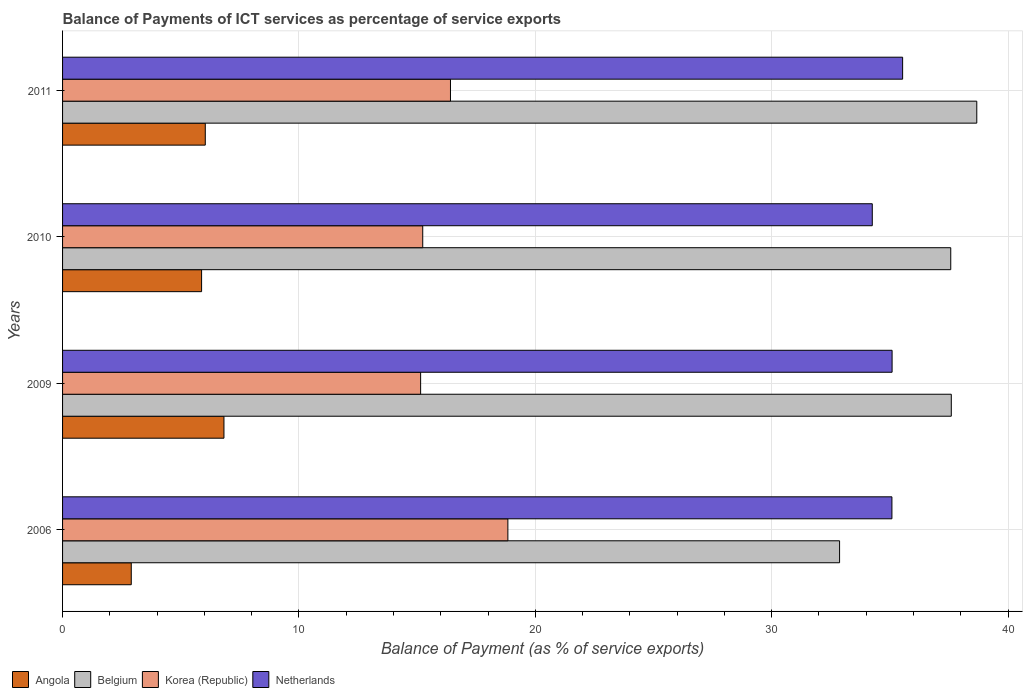How many different coloured bars are there?
Make the answer very short. 4. Are the number of bars per tick equal to the number of legend labels?
Keep it short and to the point. Yes. How many bars are there on the 3rd tick from the top?
Your answer should be compact. 4. In how many cases, is the number of bars for a given year not equal to the number of legend labels?
Give a very brief answer. 0. What is the balance of payments of ICT services in Belgium in 2011?
Make the answer very short. 38.68. Across all years, what is the maximum balance of payments of ICT services in Angola?
Make the answer very short. 6.83. Across all years, what is the minimum balance of payments of ICT services in Belgium?
Your response must be concise. 32.87. In which year was the balance of payments of ICT services in Netherlands maximum?
Your answer should be very brief. 2011. In which year was the balance of payments of ICT services in Netherlands minimum?
Ensure brevity in your answer.  2010. What is the total balance of payments of ICT services in Korea (Republic) in the graph?
Give a very brief answer. 65.63. What is the difference between the balance of payments of ICT services in Korea (Republic) in 2009 and that in 2011?
Your answer should be very brief. -1.26. What is the difference between the balance of payments of ICT services in Korea (Republic) in 2006 and the balance of payments of ICT services in Angola in 2011?
Give a very brief answer. 12.8. What is the average balance of payments of ICT services in Angola per year?
Provide a short and direct response. 5.41. In the year 2009, what is the difference between the balance of payments of ICT services in Netherlands and balance of payments of ICT services in Belgium?
Your response must be concise. -2.5. In how many years, is the balance of payments of ICT services in Belgium greater than 2 %?
Give a very brief answer. 4. What is the ratio of the balance of payments of ICT services in Belgium in 2006 to that in 2009?
Offer a very short reply. 0.87. Is the balance of payments of ICT services in Angola in 2006 less than that in 2009?
Your answer should be very brief. Yes. Is the difference between the balance of payments of ICT services in Netherlands in 2006 and 2011 greater than the difference between the balance of payments of ICT services in Belgium in 2006 and 2011?
Keep it short and to the point. Yes. What is the difference between the highest and the second highest balance of payments of ICT services in Netherlands?
Your response must be concise. 0.45. What is the difference between the highest and the lowest balance of payments of ICT services in Korea (Republic)?
Your response must be concise. 3.69. In how many years, is the balance of payments of ICT services in Netherlands greater than the average balance of payments of ICT services in Netherlands taken over all years?
Provide a short and direct response. 3. Is the sum of the balance of payments of ICT services in Korea (Republic) in 2006 and 2010 greater than the maximum balance of payments of ICT services in Belgium across all years?
Offer a terse response. No. Is it the case that in every year, the sum of the balance of payments of ICT services in Angola and balance of payments of ICT services in Netherlands is greater than the balance of payments of ICT services in Korea (Republic)?
Your response must be concise. Yes. How many bars are there?
Offer a very short reply. 16. Are all the bars in the graph horizontal?
Make the answer very short. Yes. How many years are there in the graph?
Ensure brevity in your answer.  4. What is the difference between two consecutive major ticks on the X-axis?
Your answer should be very brief. 10. Are the values on the major ticks of X-axis written in scientific E-notation?
Give a very brief answer. No. Where does the legend appear in the graph?
Offer a very short reply. Bottom left. How many legend labels are there?
Provide a short and direct response. 4. How are the legend labels stacked?
Your response must be concise. Horizontal. What is the title of the graph?
Provide a short and direct response. Balance of Payments of ICT services as percentage of service exports. What is the label or title of the X-axis?
Make the answer very short. Balance of Payment (as % of service exports). What is the label or title of the Y-axis?
Offer a terse response. Years. What is the Balance of Payment (as % of service exports) in Angola in 2006?
Provide a short and direct response. 2.91. What is the Balance of Payment (as % of service exports) in Belgium in 2006?
Your answer should be compact. 32.87. What is the Balance of Payment (as % of service exports) of Korea (Republic) in 2006?
Give a very brief answer. 18.84. What is the Balance of Payment (as % of service exports) in Netherlands in 2006?
Make the answer very short. 35.09. What is the Balance of Payment (as % of service exports) in Angola in 2009?
Keep it short and to the point. 6.83. What is the Balance of Payment (as % of service exports) in Belgium in 2009?
Offer a terse response. 37.6. What is the Balance of Payment (as % of service exports) in Korea (Republic) in 2009?
Give a very brief answer. 15.15. What is the Balance of Payment (as % of service exports) of Netherlands in 2009?
Ensure brevity in your answer.  35.09. What is the Balance of Payment (as % of service exports) of Angola in 2010?
Offer a very short reply. 5.88. What is the Balance of Payment (as % of service exports) in Belgium in 2010?
Ensure brevity in your answer.  37.57. What is the Balance of Payment (as % of service exports) in Korea (Republic) in 2010?
Offer a terse response. 15.24. What is the Balance of Payment (as % of service exports) of Netherlands in 2010?
Your response must be concise. 34.25. What is the Balance of Payment (as % of service exports) in Angola in 2011?
Your response must be concise. 6.04. What is the Balance of Payment (as % of service exports) of Belgium in 2011?
Your response must be concise. 38.68. What is the Balance of Payment (as % of service exports) of Korea (Republic) in 2011?
Your response must be concise. 16.41. What is the Balance of Payment (as % of service exports) of Netherlands in 2011?
Provide a succinct answer. 35.54. Across all years, what is the maximum Balance of Payment (as % of service exports) of Angola?
Offer a very short reply. 6.83. Across all years, what is the maximum Balance of Payment (as % of service exports) of Belgium?
Your answer should be very brief. 38.68. Across all years, what is the maximum Balance of Payment (as % of service exports) of Korea (Republic)?
Your answer should be very brief. 18.84. Across all years, what is the maximum Balance of Payment (as % of service exports) in Netherlands?
Your answer should be compact. 35.54. Across all years, what is the minimum Balance of Payment (as % of service exports) in Angola?
Provide a succinct answer. 2.91. Across all years, what is the minimum Balance of Payment (as % of service exports) of Belgium?
Make the answer very short. 32.87. Across all years, what is the minimum Balance of Payment (as % of service exports) in Korea (Republic)?
Offer a very short reply. 15.15. Across all years, what is the minimum Balance of Payment (as % of service exports) of Netherlands?
Your response must be concise. 34.25. What is the total Balance of Payment (as % of service exports) of Angola in the graph?
Offer a very short reply. 21.65. What is the total Balance of Payment (as % of service exports) of Belgium in the graph?
Give a very brief answer. 146.72. What is the total Balance of Payment (as % of service exports) of Korea (Republic) in the graph?
Your response must be concise. 65.63. What is the total Balance of Payment (as % of service exports) in Netherlands in the graph?
Keep it short and to the point. 139.97. What is the difference between the Balance of Payment (as % of service exports) of Angola in 2006 and that in 2009?
Your response must be concise. -3.92. What is the difference between the Balance of Payment (as % of service exports) of Belgium in 2006 and that in 2009?
Your answer should be very brief. -4.73. What is the difference between the Balance of Payment (as % of service exports) in Korea (Republic) in 2006 and that in 2009?
Offer a very short reply. 3.69. What is the difference between the Balance of Payment (as % of service exports) in Netherlands in 2006 and that in 2009?
Offer a terse response. -0.01. What is the difference between the Balance of Payment (as % of service exports) in Angola in 2006 and that in 2010?
Give a very brief answer. -2.98. What is the difference between the Balance of Payment (as % of service exports) in Belgium in 2006 and that in 2010?
Keep it short and to the point. -4.7. What is the difference between the Balance of Payment (as % of service exports) of Korea (Republic) in 2006 and that in 2010?
Offer a terse response. 3.6. What is the difference between the Balance of Payment (as % of service exports) in Netherlands in 2006 and that in 2010?
Ensure brevity in your answer.  0.83. What is the difference between the Balance of Payment (as % of service exports) in Angola in 2006 and that in 2011?
Your response must be concise. -3.13. What is the difference between the Balance of Payment (as % of service exports) in Belgium in 2006 and that in 2011?
Offer a very short reply. -5.8. What is the difference between the Balance of Payment (as % of service exports) of Korea (Republic) in 2006 and that in 2011?
Give a very brief answer. 2.43. What is the difference between the Balance of Payment (as % of service exports) in Netherlands in 2006 and that in 2011?
Ensure brevity in your answer.  -0.45. What is the difference between the Balance of Payment (as % of service exports) of Angola in 2009 and that in 2010?
Provide a short and direct response. 0.95. What is the difference between the Balance of Payment (as % of service exports) in Belgium in 2009 and that in 2010?
Your answer should be compact. 0.02. What is the difference between the Balance of Payment (as % of service exports) in Korea (Republic) in 2009 and that in 2010?
Make the answer very short. -0.09. What is the difference between the Balance of Payment (as % of service exports) in Netherlands in 2009 and that in 2010?
Provide a short and direct response. 0.84. What is the difference between the Balance of Payment (as % of service exports) in Angola in 2009 and that in 2011?
Provide a short and direct response. 0.79. What is the difference between the Balance of Payment (as % of service exports) of Belgium in 2009 and that in 2011?
Your answer should be compact. -1.08. What is the difference between the Balance of Payment (as % of service exports) of Korea (Republic) in 2009 and that in 2011?
Ensure brevity in your answer.  -1.26. What is the difference between the Balance of Payment (as % of service exports) of Netherlands in 2009 and that in 2011?
Provide a short and direct response. -0.45. What is the difference between the Balance of Payment (as % of service exports) in Angola in 2010 and that in 2011?
Keep it short and to the point. -0.16. What is the difference between the Balance of Payment (as % of service exports) in Belgium in 2010 and that in 2011?
Offer a very short reply. -1.1. What is the difference between the Balance of Payment (as % of service exports) of Korea (Republic) in 2010 and that in 2011?
Keep it short and to the point. -1.17. What is the difference between the Balance of Payment (as % of service exports) in Netherlands in 2010 and that in 2011?
Offer a terse response. -1.28. What is the difference between the Balance of Payment (as % of service exports) in Angola in 2006 and the Balance of Payment (as % of service exports) in Belgium in 2009?
Your answer should be very brief. -34.69. What is the difference between the Balance of Payment (as % of service exports) of Angola in 2006 and the Balance of Payment (as % of service exports) of Korea (Republic) in 2009?
Your answer should be compact. -12.24. What is the difference between the Balance of Payment (as % of service exports) of Angola in 2006 and the Balance of Payment (as % of service exports) of Netherlands in 2009?
Keep it short and to the point. -32.19. What is the difference between the Balance of Payment (as % of service exports) of Belgium in 2006 and the Balance of Payment (as % of service exports) of Korea (Republic) in 2009?
Provide a short and direct response. 17.72. What is the difference between the Balance of Payment (as % of service exports) in Belgium in 2006 and the Balance of Payment (as % of service exports) in Netherlands in 2009?
Give a very brief answer. -2.22. What is the difference between the Balance of Payment (as % of service exports) of Korea (Republic) in 2006 and the Balance of Payment (as % of service exports) of Netherlands in 2009?
Make the answer very short. -16.25. What is the difference between the Balance of Payment (as % of service exports) of Angola in 2006 and the Balance of Payment (as % of service exports) of Belgium in 2010?
Your answer should be compact. -34.67. What is the difference between the Balance of Payment (as % of service exports) of Angola in 2006 and the Balance of Payment (as % of service exports) of Korea (Republic) in 2010?
Make the answer very short. -12.33. What is the difference between the Balance of Payment (as % of service exports) of Angola in 2006 and the Balance of Payment (as % of service exports) of Netherlands in 2010?
Your answer should be very brief. -31.35. What is the difference between the Balance of Payment (as % of service exports) of Belgium in 2006 and the Balance of Payment (as % of service exports) of Korea (Republic) in 2010?
Offer a very short reply. 17.63. What is the difference between the Balance of Payment (as % of service exports) in Belgium in 2006 and the Balance of Payment (as % of service exports) in Netherlands in 2010?
Provide a succinct answer. -1.38. What is the difference between the Balance of Payment (as % of service exports) of Korea (Republic) in 2006 and the Balance of Payment (as % of service exports) of Netherlands in 2010?
Offer a very short reply. -15.42. What is the difference between the Balance of Payment (as % of service exports) of Angola in 2006 and the Balance of Payment (as % of service exports) of Belgium in 2011?
Ensure brevity in your answer.  -35.77. What is the difference between the Balance of Payment (as % of service exports) in Angola in 2006 and the Balance of Payment (as % of service exports) in Korea (Republic) in 2011?
Your answer should be compact. -13.5. What is the difference between the Balance of Payment (as % of service exports) of Angola in 2006 and the Balance of Payment (as % of service exports) of Netherlands in 2011?
Make the answer very short. -32.63. What is the difference between the Balance of Payment (as % of service exports) of Belgium in 2006 and the Balance of Payment (as % of service exports) of Korea (Republic) in 2011?
Offer a terse response. 16.46. What is the difference between the Balance of Payment (as % of service exports) in Belgium in 2006 and the Balance of Payment (as % of service exports) in Netherlands in 2011?
Offer a very short reply. -2.67. What is the difference between the Balance of Payment (as % of service exports) in Korea (Republic) in 2006 and the Balance of Payment (as % of service exports) in Netherlands in 2011?
Provide a short and direct response. -16.7. What is the difference between the Balance of Payment (as % of service exports) in Angola in 2009 and the Balance of Payment (as % of service exports) in Belgium in 2010?
Ensure brevity in your answer.  -30.75. What is the difference between the Balance of Payment (as % of service exports) in Angola in 2009 and the Balance of Payment (as % of service exports) in Korea (Republic) in 2010?
Provide a succinct answer. -8.41. What is the difference between the Balance of Payment (as % of service exports) in Angola in 2009 and the Balance of Payment (as % of service exports) in Netherlands in 2010?
Offer a terse response. -27.43. What is the difference between the Balance of Payment (as % of service exports) in Belgium in 2009 and the Balance of Payment (as % of service exports) in Korea (Republic) in 2010?
Your answer should be compact. 22.36. What is the difference between the Balance of Payment (as % of service exports) in Belgium in 2009 and the Balance of Payment (as % of service exports) in Netherlands in 2010?
Ensure brevity in your answer.  3.34. What is the difference between the Balance of Payment (as % of service exports) in Korea (Republic) in 2009 and the Balance of Payment (as % of service exports) in Netherlands in 2010?
Your answer should be very brief. -19.11. What is the difference between the Balance of Payment (as % of service exports) of Angola in 2009 and the Balance of Payment (as % of service exports) of Belgium in 2011?
Your response must be concise. -31.85. What is the difference between the Balance of Payment (as % of service exports) of Angola in 2009 and the Balance of Payment (as % of service exports) of Korea (Republic) in 2011?
Your answer should be very brief. -9.58. What is the difference between the Balance of Payment (as % of service exports) of Angola in 2009 and the Balance of Payment (as % of service exports) of Netherlands in 2011?
Provide a short and direct response. -28.71. What is the difference between the Balance of Payment (as % of service exports) in Belgium in 2009 and the Balance of Payment (as % of service exports) in Korea (Republic) in 2011?
Keep it short and to the point. 21.19. What is the difference between the Balance of Payment (as % of service exports) of Belgium in 2009 and the Balance of Payment (as % of service exports) of Netherlands in 2011?
Keep it short and to the point. 2.06. What is the difference between the Balance of Payment (as % of service exports) of Korea (Republic) in 2009 and the Balance of Payment (as % of service exports) of Netherlands in 2011?
Your answer should be compact. -20.39. What is the difference between the Balance of Payment (as % of service exports) of Angola in 2010 and the Balance of Payment (as % of service exports) of Belgium in 2011?
Offer a terse response. -32.79. What is the difference between the Balance of Payment (as % of service exports) in Angola in 2010 and the Balance of Payment (as % of service exports) in Korea (Republic) in 2011?
Ensure brevity in your answer.  -10.53. What is the difference between the Balance of Payment (as % of service exports) in Angola in 2010 and the Balance of Payment (as % of service exports) in Netherlands in 2011?
Offer a terse response. -29.66. What is the difference between the Balance of Payment (as % of service exports) in Belgium in 2010 and the Balance of Payment (as % of service exports) in Korea (Republic) in 2011?
Give a very brief answer. 21.16. What is the difference between the Balance of Payment (as % of service exports) of Belgium in 2010 and the Balance of Payment (as % of service exports) of Netherlands in 2011?
Keep it short and to the point. 2.04. What is the difference between the Balance of Payment (as % of service exports) in Korea (Republic) in 2010 and the Balance of Payment (as % of service exports) in Netherlands in 2011?
Offer a terse response. -20.3. What is the average Balance of Payment (as % of service exports) in Angola per year?
Ensure brevity in your answer.  5.41. What is the average Balance of Payment (as % of service exports) in Belgium per year?
Keep it short and to the point. 36.68. What is the average Balance of Payment (as % of service exports) in Korea (Republic) per year?
Give a very brief answer. 16.41. What is the average Balance of Payment (as % of service exports) of Netherlands per year?
Ensure brevity in your answer.  34.99. In the year 2006, what is the difference between the Balance of Payment (as % of service exports) in Angola and Balance of Payment (as % of service exports) in Belgium?
Offer a very short reply. -29.96. In the year 2006, what is the difference between the Balance of Payment (as % of service exports) of Angola and Balance of Payment (as % of service exports) of Korea (Republic)?
Give a very brief answer. -15.93. In the year 2006, what is the difference between the Balance of Payment (as % of service exports) in Angola and Balance of Payment (as % of service exports) in Netherlands?
Provide a short and direct response. -32.18. In the year 2006, what is the difference between the Balance of Payment (as % of service exports) in Belgium and Balance of Payment (as % of service exports) in Korea (Republic)?
Ensure brevity in your answer.  14.03. In the year 2006, what is the difference between the Balance of Payment (as % of service exports) in Belgium and Balance of Payment (as % of service exports) in Netherlands?
Your response must be concise. -2.21. In the year 2006, what is the difference between the Balance of Payment (as % of service exports) of Korea (Republic) and Balance of Payment (as % of service exports) of Netherlands?
Give a very brief answer. -16.25. In the year 2009, what is the difference between the Balance of Payment (as % of service exports) of Angola and Balance of Payment (as % of service exports) of Belgium?
Offer a terse response. -30.77. In the year 2009, what is the difference between the Balance of Payment (as % of service exports) of Angola and Balance of Payment (as % of service exports) of Korea (Republic)?
Your response must be concise. -8.32. In the year 2009, what is the difference between the Balance of Payment (as % of service exports) in Angola and Balance of Payment (as % of service exports) in Netherlands?
Ensure brevity in your answer.  -28.27. In the year 2009, what is the difference between the Balance of Payment (as % of service exports) in Belgium and Balance of Payment (as % of service exports) in Korea (Republic)?
Ensure brevity in your answer.  22.45. In the year 2009, what is the difference between the Balance of Payment (as % of service exports) in Belgium and Balance of Payment (as % of service exports) in Netherlands?
Provide a succinct answer. 2.5. In the year 2009, what is the difference between the Balance of Payment (as % of service exports) in Korea (Republic) and Balance of Payment (as % of service exports) in Netherlands?
Offer a terse response. -19.94. In the year 2010, what is the difference between the Balance of Payment (as % of service exports) of Angola and Balance of Payment (as % of service exports) of Belgium?
Offer a very short reply. -31.69. In the year 2010, what is the difference between the Balance of Payment (as % of service exports) of Angola and Balance of Payment (as % of service exports) of Korea (Republic)?
Provide a short and direct response. -9.36. In the year 2010, what is the difference between the Balance of Payment (as % of service exports) of Angola and Balance of Payment (as % of service exports) of Netherlands?
Your response must be concise. -28.37. In the year 2010, what is the difference between the Balance of Payment (as % of service exports) of Belgium and Balance of Payment (as % of service exports) of Korea (Republic)?
Make the answer very short. 22.34. In the year 2010, what is the difference between the Balance of Payment (as % of service exports) of Belgium and Balance of Payment (as % of service exports) of Netherlands?
Give a very brief answer. 3.32. In the year 2010, what is the difference between the Balance of Payment (as % of service exports) of Korea (Republic) and Balance of Payment (as % of service exports) of Netherlands?
Provide a succinct answer. -19.02. In the year 2011, what is the difference between the Balance of Payment (as % of service exports) in Angola and Balance of Payment (as % of service exports) in Belgium?
Your response must be concise. -32.64. In the year 2011, what is the difference between the Balance of Payment (as % of service exports) of Angola and Balance of Payment (as % of service exports) of Korea (Republic)?
Offer a terse response. -10.37. In the year 2011, what is the difference between the Balance of Payment (as % of service exports) of Angola and Balance of Payment (as % of service exports) of Netherlands?
Give a very brief answer. -29.5. In the year 2011, what is the difference between the Balance of Payment (as % of service exports) of Belgium and Balance of Payment (as % of service exports) of Korea (Republic)?
Offer a very short reply. 22.27. In the year 2011, what is the difference between the Balance of Payment (as % of service exports) in Belgium and Balance of Payment (as % of service exports) in Netherlands?
Provide a short and direct response. 3.14. In the year 2011, what is the difference between the Balance of Payment (as % of service exports) in Korea (Republic) and Balance of Payment (as % of service exports) in Netherlands?
Offer a terse response. -19.13. What is the ratio of the Balance of Payment (as % of service exports) in Angola in 2006 to that in 2009?
Your answer should be very brief. 0.43. What is the ratio of the Balance of Payment (as % of service exports) in Belgium in 2006 to that in 2009?
Your response must be concise. 0.87. What is the ratio of the Balance of Payment (as % of service exports) of Korea (Republic) in 2006 to that in 2009?
Your response must be concise. 1.24. What is the ratio of the Balance of Payment (as % of service exports) of Netherlands in 2006 to that in 2009?
Keep it short and to the point. 1. What is the ratio of the Balance of Payment (as % of service exports) of Angola in 2006 to that in 2010?
Offer a very short reply. 0.49. What is the ratio of the Balance of Payment (as % of service exports) of Belgium in 2006 to that in 2010?
Provide a succinct answer. 0.87. What is the ratio of the Balance of Payment (as % of service exports) of Korea (Republic) in 2006 to that in 2010?
Offer a very short reply. 1.24. What is the ratio of the Balance of Payment (as % of service exports) in Netherlands in 2006 to that in 2010?
Your answer should be compact. 1.02. What is the ratio of the Balance of Payment (as % of service exports) of Angola in 2006 to that in 2011?
Ensure brevity in your answer.  0.48. What is the ratio of the Balance of Payment (as % of service exports) of Belgium in 2006 to that in 2011?
Provide a succinct answer. 0.85. What is the ratio of the Balance of Payment (as % of service exports) of Korea (Republic) in 2006 to that in 2011?
Your response must be concise. 1.15. What is the ratio of the Balance of Payment (as % of service exports) of Netherlands in 2006 to that in 2011?
Your answer should be very brief. 0.99. What is the ratio of the Balance of Payment (as % of service exports) in Angola in 2009 to that in 2010?
Offer a terse response. 1.16. What is the ratio of the Balance of Payment (as % of service exports) in Netherlands in 2009 to that in 2010?
Keep it short and to the point. 1.02. What is the ratio of the Balance of Payment (as % of service exports) of Angola in 2009 to that in 2011?
Give a very brief answer. 1.13. What is the ratio of the Balance of Payment (as % of service exports) of Belgium in 2009 to that in 2011?
Make the answer very short. 0.97. What is the ratio of the Balance of Payment (as % of service exports) of Netherlands in 2009 to that in 2011?
Your answer should be compact. 0.99. What is the ratio of the Balance of Payment (as % of service exports) in Angola in 2010 to that in 2011?
Provide a short and direct response. 0.97. What is the ratio of the Balance of Payment (as % of service exports) in Belgium in 2010 to that in 2011?
Offer a terse response. 0.97. What is the ratio of the Balance of Payment (as % of service exports) of Korea (Republic) in 2010 to that in 2011?
Your answer should be compact. 0.93. What is the ratio of the Balance of Payment (as % of service exports) in Netherlands in 2010 to that in 2011?
Your response must be concise. 0.96. What is the difference between the highest and the second highest Balance of Payment (as % of service exports) of Angola?
Keep it short and to the point. 0.79. What is the difference between the highest and the second highest Balance of Payment (as % of service exports) of Belgium?
Your response must be concise. 1.08. What is the difference between the highest and the second highest Balance of Payment (as % of service exports) of Korea (Republic)?
Offer a terse response. 2.43. What is the difference between the highest and the second highest Balance of Payment (as % of service exports) of Netherlands?
Your answer should be very brief. 0.45. What is the difference between the highest and the lowest Balance of Payment (as % of service exports) of Angola?
Give a very brief answer. 3.92. What is the difference between the highest and the lowest Balance of Payment (as % of service exports) in Belgium?
Provide a short and direct response. 5.8. What is the difference between the highest and the lowest Balance of Payment (as % of service exports) of Korea (Republic)?
Keep it short and to the point. 3.69. What is the difference between the highest and the lowest Balance of Payment (as % of service exports) in Netherlands?
Offer a terse response. 1.28. 